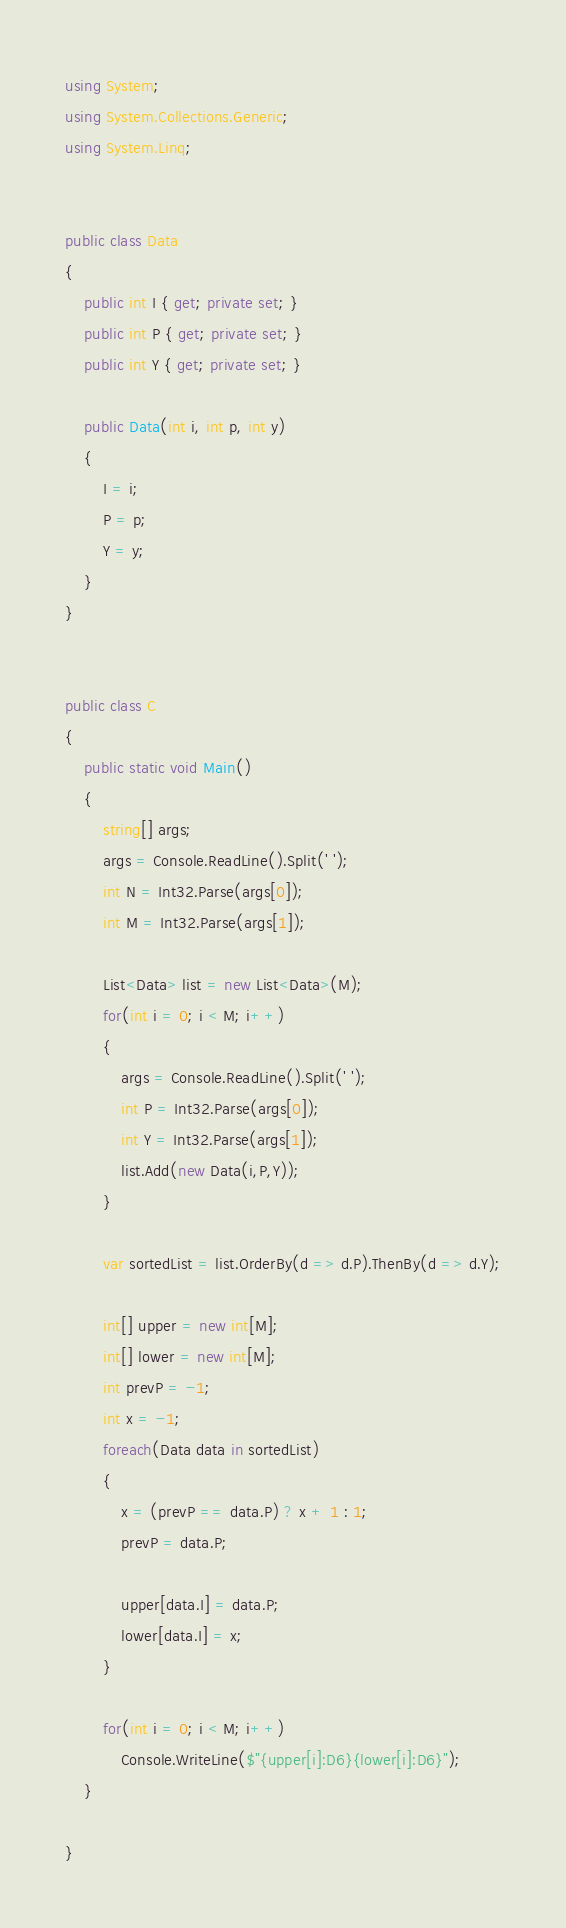Convert code to text. <code><loc_0><loc_0><loc_500><loc_500><_C#_>using System;
using System.Collections.Generic;
using System.Linq;


public class Data
{
	public int I { get; private set; }
	public int P { get; private set; }
	public int Y { get; private set; }
	
	public Data(int i, int p, int y)
	{
		I = i;
		P = p;
		Y = y;		
	}	
}


public class C
{	
	public static void Main()
	{	
		string[] args;
		args = Console.ReadLine().Split(' ');
		int N = Int32.Parse(args[0]);
		int M = Int32.Parse(args[1]);
		
		List<Data> list = new List<Data>(M);
		for(int i = 0; i < M; i++)
		{
			args = Console.ReadLine().Split(' ');
			int P = Int32.Parse(args[0]);
			int Y = Int32.Parse(args[1]);
			list.Add(new Data(i,P,Y));			
		}	
		
		var sortedList = list.OrderBy(d => d.P).ThenBy(d => d.Y);
		
		int[] upper = new int[M];
		int[] lower = new int[M];
		int prevP = -1;
		int x = -1;
		foreach(Data data in sortedList)
		{
			x = (prevP == data.P) ? x + 1 : 1;
			prevP = data.P;
			
			upper[data.I] = data.P;
			lower[data.I] = x;
		}
		
		for(int i = 0; i < M; i++)
			Console.WriteLine($"{upper[i]:D6}{lower[i]:D6}");
	}
	
}</code> 